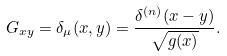<formula> <loc_0><loc_0><loc_500><loc_500>G _ { x y } = \delta _ { \mu } ( x , y ) = \frac { \delta ^ { ( n ) } ( x - y ) } { \sqrt { g ( x ) } } .</formula> 